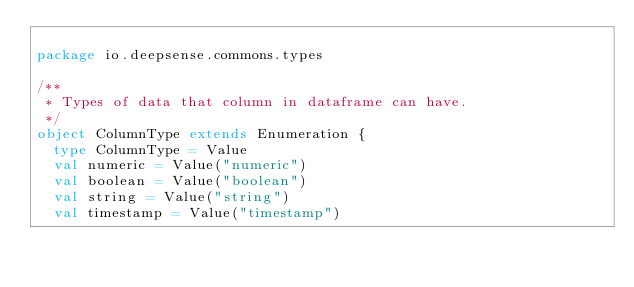<code> <loc_0><loc_0><loc_500><loc_500><_Scala_>
package io.deepsense.commons.types

/**
 * Types of data that column in dataframe can have.
 */
object ColumnType extends Enumeration {
  type ColumnType = Value
  val numeric = Value("numeric")
  val boolean = Value("boolean")
  val string = Value("string")
  val timestamp = Value("timestamp")
</code> 